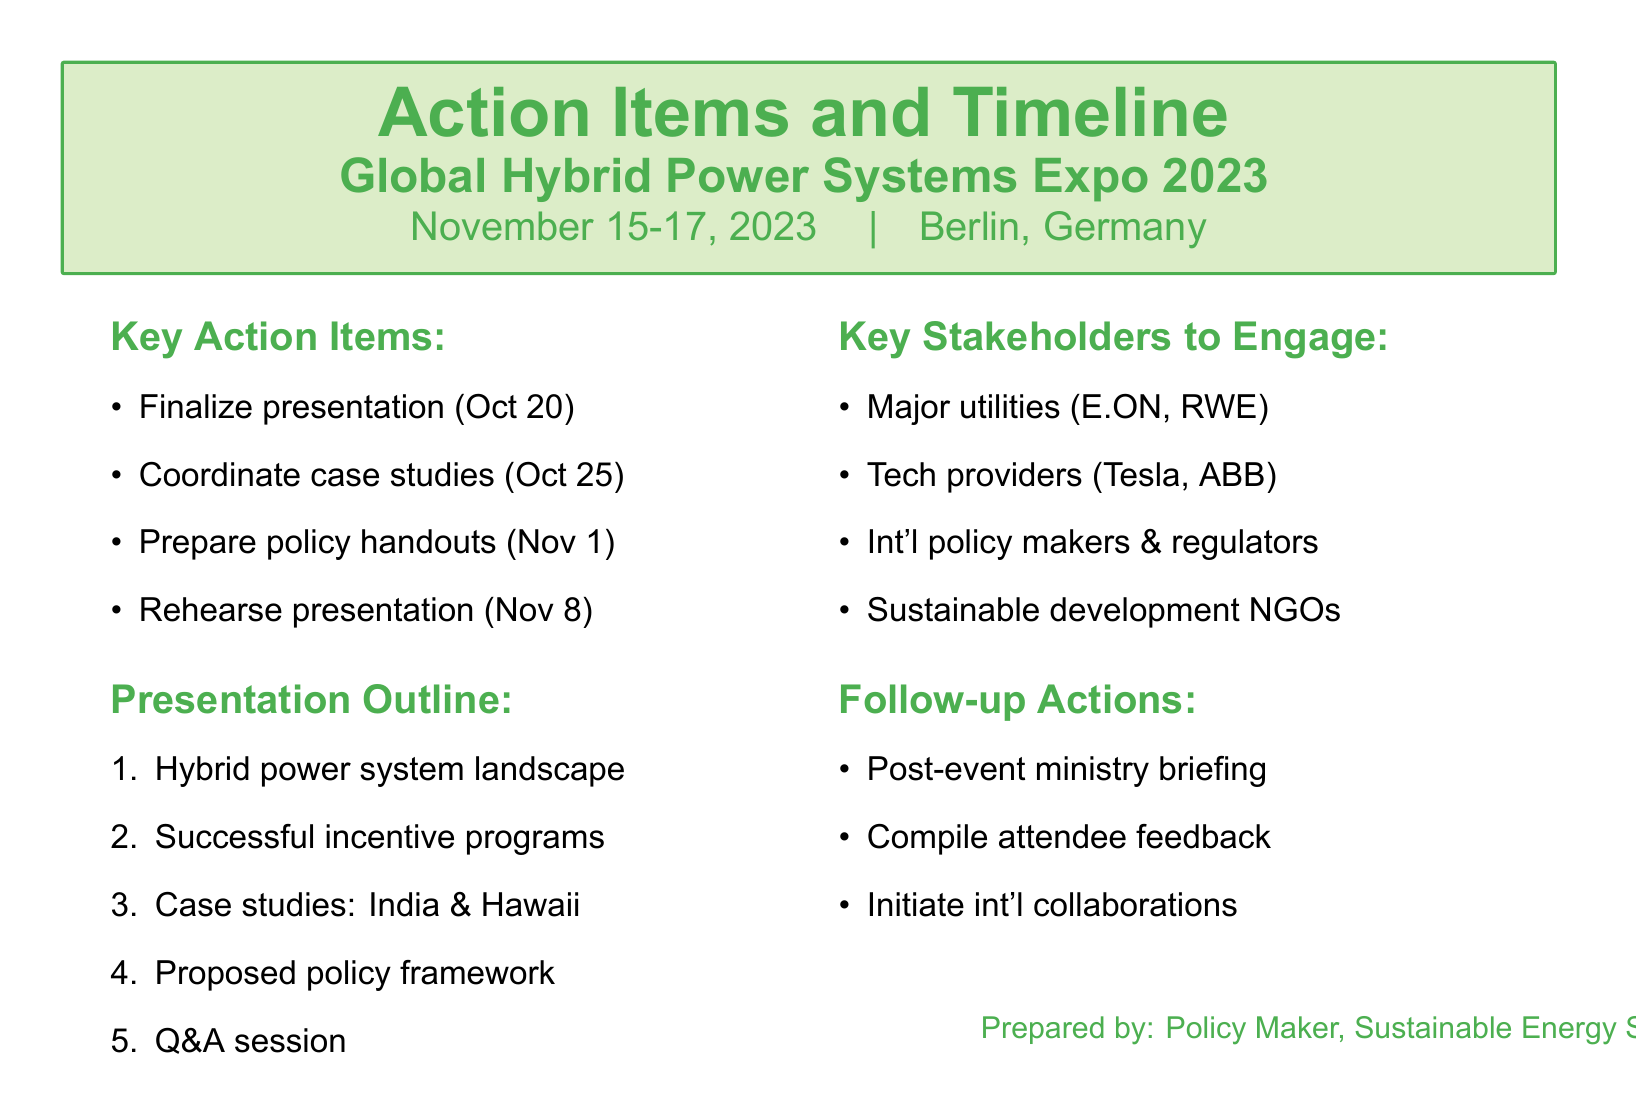What is the name of the event? The name of the event is mentioned in the document as "Global Hybrid Power Systems Expo 2023."
Answer: Global Hybrid Power Systems Expo 2023 When is the deadline to finalize the presentation? The deadline to finalize the presentation is listed as "October 20, 2023."
Answer: October 20, 2023 What are the two case study locations mentioned? The document lists the case study locations as "Rural electrification project in India" and "Island grid stability in Hawaii."
Answer: India, Hawaii Who are two of the key stakeholders to engage? The document specifies stakeholders, including "E.ON" and "Tesla."
Answer: E.ON, Tesla What is one of the follow-up actions listed? The document states that one follow-up action is to "Schedule post-event briefing with ministry officials."
Answer: Schedule post-event briefing with ministry officials What is the presentation outline's first topic? The first topic of the presentation outline is "Introduction to current hybrid power system landscape."
Answer: Introduction to current hybrid power system landscape How many days are there until the event from the final preparation date? The reaction involves calculating from the final action item date to the event date, resulting in 28 days.
Answer: 28 days What is the location of the event? The document specifies the location of the event as "Berlin, Germany."
Answer: Berlin, Germany 